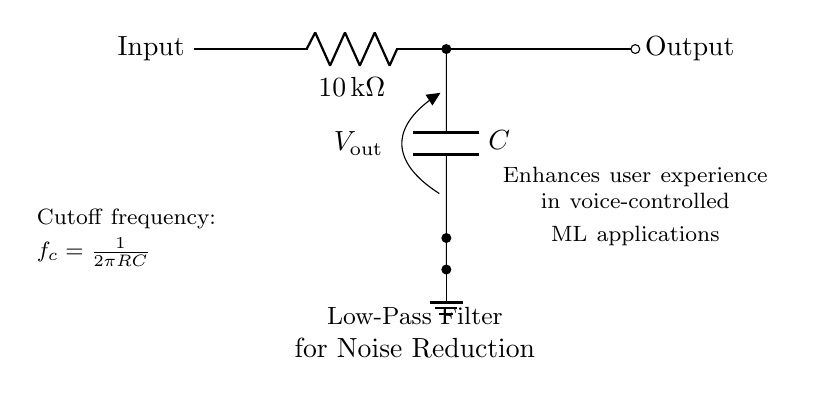What is the type of filter represented in the circuit? The circuit is a low-pass filter, which allows signals below a certain frequency to pass while attenuating higher frequencies.
Answer: low-pass filter What is the value of the resistor in the circuit? The resistor in the circuit is labeled with a value of ten kilohms, which indicates its resistance.
Answer: 10 kilohms What is the output voltage denoted as in the circuit? The output voltage in the circuit is specified as Vout, indicating the voltage at the output side after filtering.
Answer: Vout What is the purpose of this filter in audio applications? The purpose of the low-pass filter is to reduce noise in audio interfaces, allowing for clearer audio signals in voice-controlled applications.
Answer: noise reduction How is the cutoff frequency for this filter determined? The cutoff frequency is calculated using the formula f_c = 1 / (2πRC), where R is the resistance and C is the capacitance, indicating the frequency point where the output power is half of the input power.
Answer: f_c = 1 / (2πRC) What will happen to frequencies above the cutoff frequency? Frequencies above the cutoff frequency will be attenuated, meaning they will be reduced in amplitude, which helps to clean up the audio signal by removing unwanted high-frequency noise.
Answer: attenuated What components make up the filter circuit? The filter circuit is composed of a resistor and a capacitor, which work together to accomplish the low-pass filtering effect.
Answer: resistor and capacitor 